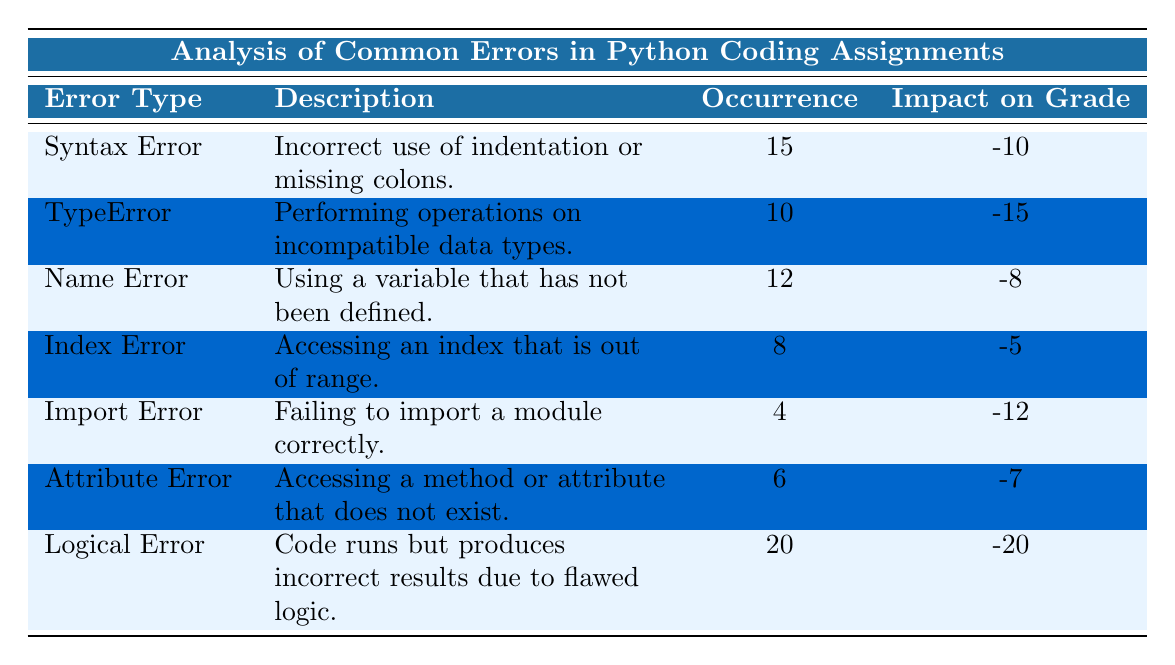What is the total occurrence of Logical Error? The occurrence of Logical Error is listed in the table, which states it has occurred 20 times.
Answer: 20 What error type has the highest impact on grade? By examining the "Impact on Grade" column, Logical Error has the largest negative impact of -20, which is more significant than any other error type.
Answer: Logical Error What is the average impact on grade for all errors? First, sum all the impact values: -10 + -15 + -8 + -5 + -12 + -7 + -20 = -77. Next, divide by the number of error types, which is 7: -77 / 7 = -11. Therefore, the average impact on grade for all errors is -11.
Answer: -11 Is there an error type with less than 10 occurrences? By checking the "Occurrence" column, both Import Error (4 occurrences) and Index Error (8 occurrences) have occurrences less than 10. Therefore, the answer to the question is yes.
Answer: Yes What is the difference in occurrence between Syntax Error and Name Error? The occurrence for Syntax Error is 15, and for Name Error it is 12. To find the difference, subtract 12 from 15, resulting in 3.
Answer: 3 Which error is most frequent among TypeError, Attribute Error, and Index Error? Looking at the occurrences, TypeError has 10, Attribute Error has 6, and Index Error has 8. The highest occurrence is TypeError.
Answer: TypeError What is the cumulative impact of both Syntax Error and Import Error on final grades? The impact for Syntax Error is -10 and for Import Error is -12. Adding these impacts together gives: -10 + -12 = -22.
Answer: -22 